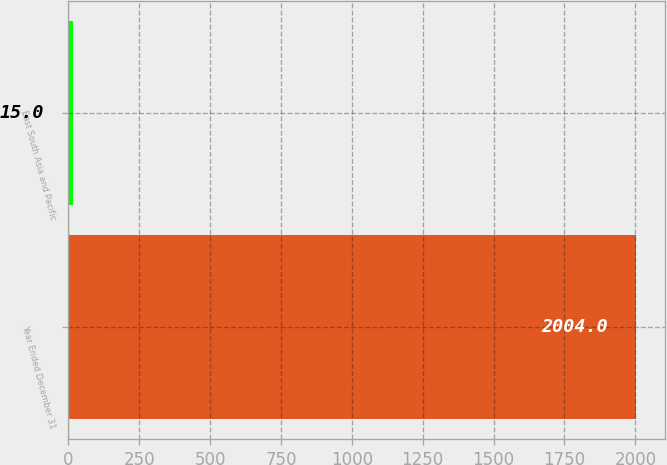Convert chart. <chart><loc_0><loc_0><loc_500><loc_500><bar_chart><fcel>Year Ended December 31<fcel>East South Asia and Pacific<nl><fcel>2004<fcel>15<nl></chart> 